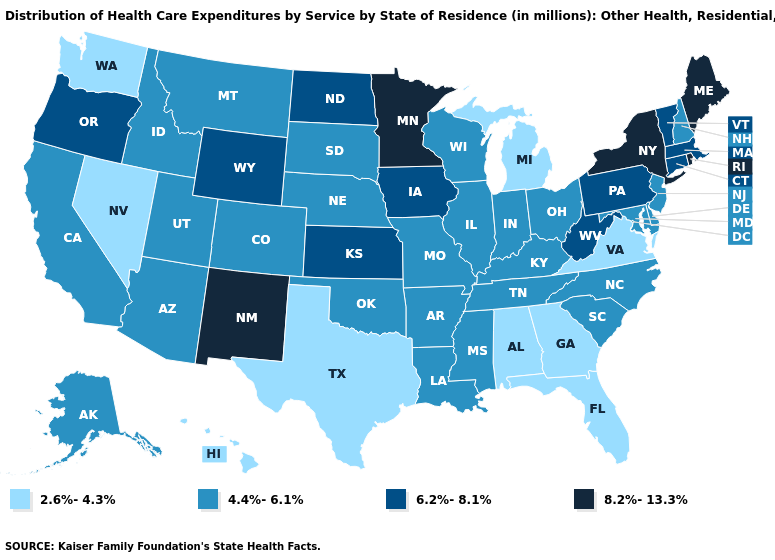What is the value of Missouri?
Quick response, please. 4.4%-6.1%. What is the lowest value in the Northeast?
Quick response, please. 4.4%-6.1%. Which states have the highest value in the USA?
Give a very brief answer. Maine, Minnesota, New Mexico, New York, Rhode Island. What is the value of Oklahoma?
Answer briefly. 4.4%-6.1%. What is the highest value in the USA?
Answer briefly. 8.2%-13.3%. Does Oklahoma have a lower value than New Mexico?
Be succinct. Yes. What is the lowest value in the USA?
Answer briefly. 2.6%-4.3%. Which states have the lowest value in the West?
Short answer required. Hawaii, Nevada, Washington. What is the value of Oregon?
Keep it brief. 6.2%-8.1%. Name the states that have a value in the range 6.2%-8.1%?
Write a very short answer. Connecticut, Iowa, Kansas, Massachusetts, North Dakota, Oregon, Pennsylvania, Vermont, West Virginia, Wyoming. Which states have the highest value in the USA?
Be succinct. Maine, Minnesota, New Mexico, New York, Rhode Island. Does Oregon have the highest value in the West?
Keep it brief. No. What is the highest value in states that border Wyoming?
Short answer required. 4.4%-6.1%. What is the value of Montana?
Short answer required. 4.4%-6.1%. Which states have the highest value in the USA?
Write a very short answer. Maine, Minnesota, New Mexico, New York, Rhode Island. 